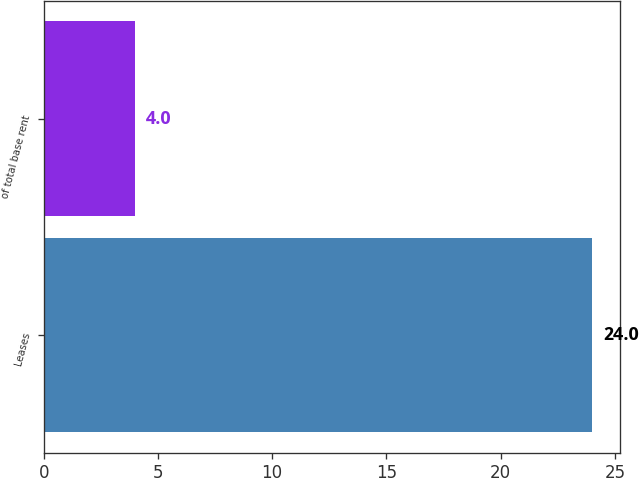<chart> <loc_0><loc_0><loc_500><loc_500><bar_chart><fcel>Leases<fcel>of total base rent<nl><fcel>24<fcel>4<nl></chart> 